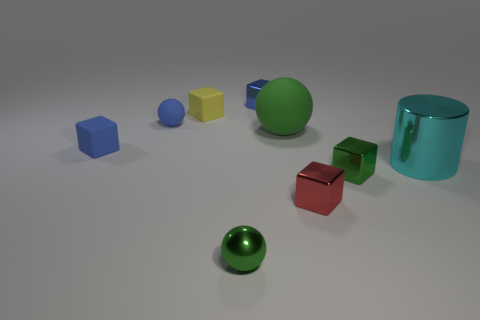Subtract 1 cubes. How many cubes are left? 4 Subtract all green cubes. How many cubes are left? 4 Subtract all tiny green blocks. How many blocks are left? 4 Subtract all purple blocks. Subtract all blue cylinders. How many blocks are left? 5 Add 1 green things. How many objects exist? 10 Subtract all blocks. How many objects are left? 4 Subtract 0 gray spheres. How many objects are left? 9 Subtract all small rubber blocks. Subtract all small green blocks. How many objects are left? 6 Add 4 blocks. How many blocks are left? 9 Add 9 tiny blue metallic blocks. How many tiny blue metallic blocks exist? 10 